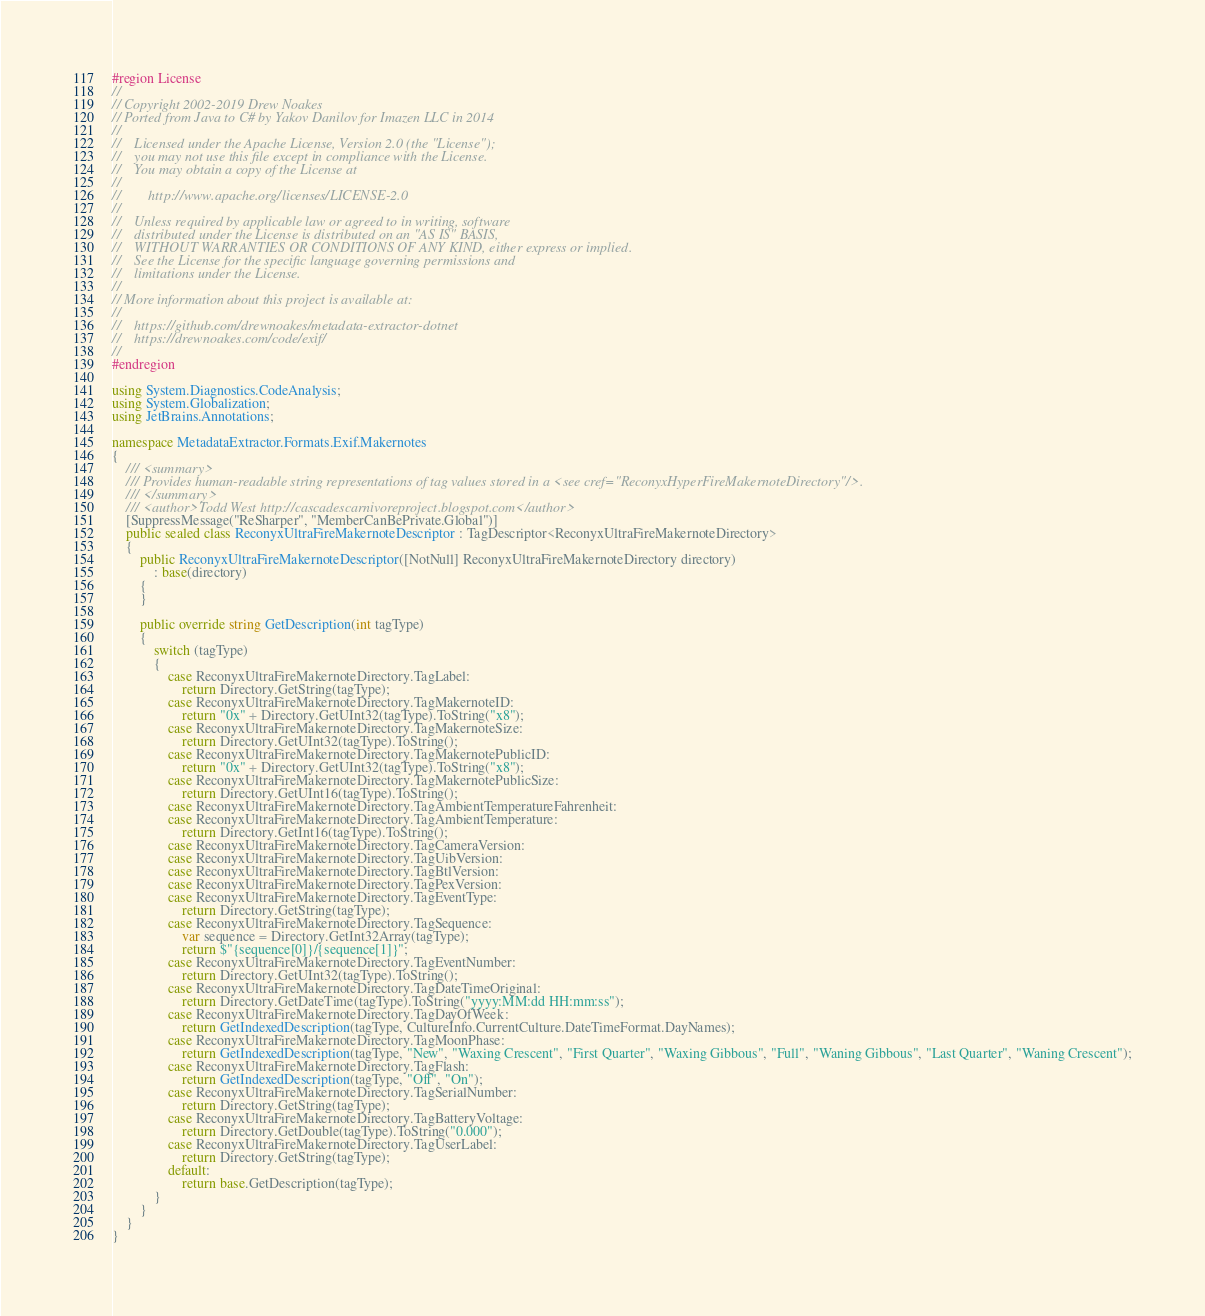<code> <loc_0><loc_0><loc_500><loc_500><_C#_>#region License
//
// Copyright 2002-2019 Drew Noakes
// Ported from Java to C# by Yakov Danilov for Imazen LLC in 2014
//
//    Licensed under the Apache License, Version 2.0 (the "License");
//    you may not use this file except in compliance with the License.
//    You may obtain a copy of the License at
//
//        http://www.apache.org/licenses/LICENSE-2.0
//
//    Unless required by applicable law or agreed to in writing, software
//    distributed under the License is distributed on an "AS IS" BASIS,
//    WITHOUT WARRANTIES OR CONDITIONS OF ANY KIND, either express or implied.
//    See the License for the specific language governing permissions and
//    limitations under the License.
//
// More information about this project is available at:
//
//    https://github.com/drewnoakes/metadata-extractor-dotnet
//    https://drewnoakes.com/code/exif/
//
#endregion

using System.Diagnostics.CodeAnalysis;
using System.Globalization;
using JetBrains.Annotations;

namespace MetadataExtractor.Formats.Exif.Makernotes
{
    /// <summary>
    /// Provides human-readable string representations of tag values stored in a <see cref="ReconyxHyperFireMakernoteDirectory"/>.
    /// </summary>
    /// <author>Todd West http://cascadescarnivoreproject.blogspot.com</author>
    [SuppressMessage("ReSharper", "MemberCanBePrivate.Global")]
    public sealed class ReconyxUltraFireMakernoteDescriptor : TagDescriptor<ReconyxUltraFireMakernoteDirectory>
    {
        public ReconyxUltraFireMakernoteDescriptor([NotNull] ReconyxUltraFireMakernoteDirectory directory)
            : base(directory)
        {
        }

        public override string GetDescription(int tagType)
        {
            switch (tagType)
            {
                case ReconyxUltraFireMakernoteDirectory.TagLabel:
                    return Directory.GetString(tagType);
                case ReconyxUltraFireMakernoteDirectory.TagMakernoteID:
                    return "0x" + Directory.GetUInt32(tagType).ToString("x8");
                case ReconyxUltraFireMakernoteDirectory.TagMakernoteSize:
                    return Directory.GetUInt32(tagType).ToString();
                case ReconyxUltraFireMakernoteDirectory.TagMakernotePublicID:
                    return "0x" + Directory.GetUInt32(tagType).ToString("x8");
                case ReconyxUltraFireMakernoteDirectory.TagMakernotePublicSize:
                    return Directory.GetUInt16(tagType).ToString();
                case ReconyxUltraFireMakernoteDirectory.TagAmbientTemperatureFahrenheit:
                case ReconyxUltraFireMakernoteDirectory.TagAmbientTemperature:
                    return Directory.GetInt16(tagType).ToString();
                case ReconyxUltraFireMakernoteDirectory.TagCameraVersion:
                case ReconyxUltraFireMakernoteDirectory.TagUibVersion:
                case ReconyxUltraFireMakernoteDirectory.TagBtlVersion:
                case ReconyxUltraFireMakernoteDirectory.TagPexVersion:
                case ReconyxUltraFireMakernoteDirectory.TagEventType:
                    return Directory.GetString(tagType);
                case ReconyxUltraFireMakernoteDirectory.TagSequence:
                    var sequence = Directory.GetInt32Array(tagType);
                    return $"{sequence[0]}/{sequence[1]}";
                case ReconyxUltraFireMakernoteDirectory.TagEventNumber:
                    return Directory.GetUInt32(tagType).ToString();
                case ReconyxUltraFireMakernoteDirectory.TagDateTimeOriginal:
                    return Directory.GetDateTime(tagType).ToString("yyyy:MM:dd HH:mm:ss");
                case ReconyxUltraFireMakernoteDirectory.TagDayOfWeek:
                    return GetIndexedDescription(tagType, CultureInfo.CurrentCulture.DateTimeFormat.DayNames);
                case ReconyxUltraFireMakernoteDirectory.TagMoonPhase:
                    return GetIndexedDescription(tagType, "New", "Waxing Crescent", "First Quarter", "Waxing Gibbous", "Full", "Waning Gibbous", "Last Quarter", "Waning Crescent");
                case ReconyxUltraFireMakernoteDirectory.TagFlash:
                    return GetIndexedDescription(tagType, "Off", "On");
                case ReconyxUltraFireMakernoteDirectory.TagSerialNumber:
                    return Directory.GetString(tagType);
                case ReconyxUltraFireMakernoteDirectory.TagBatteryVoltage:
                    return Directory.GetDouble(tagType).ToString("0.000");
                case ReconyxUltraFireMakernoteDirectory.TagUserLabel:
                    return Directory.GetString(tagType);
                default:
                    return base.GetDescription(tagType);
            }
        }
    }
}
</code> 